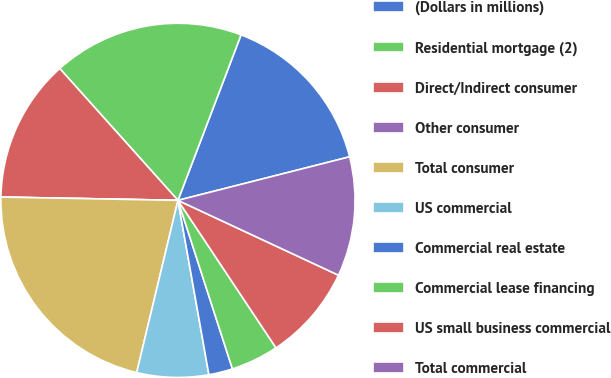Convert chart to OTSL. <chart><loc_0><loc_0><loc_500><loc_500><pie_chart><fcel>(Dollars in millions)<fcel>Residential mortgage (2)<fcel>Direct/Indirect consumer<fcel>Other consumer<fcel>Total consumer<fcel>US commercial<fcel>Commercial real estate<fcel>Commercial lease financing<fcel>US small business commercial<fcel>Total commercial<nl><fcel>15.25%<fcel>17.43%<fcel>13.07%<fcel>0.0%<fcel>21.55%<fcel>6.54%<fcel>2.18%<fcel>4.36%<fcel>8.72%<fcel>10.9%<nl></chart> 